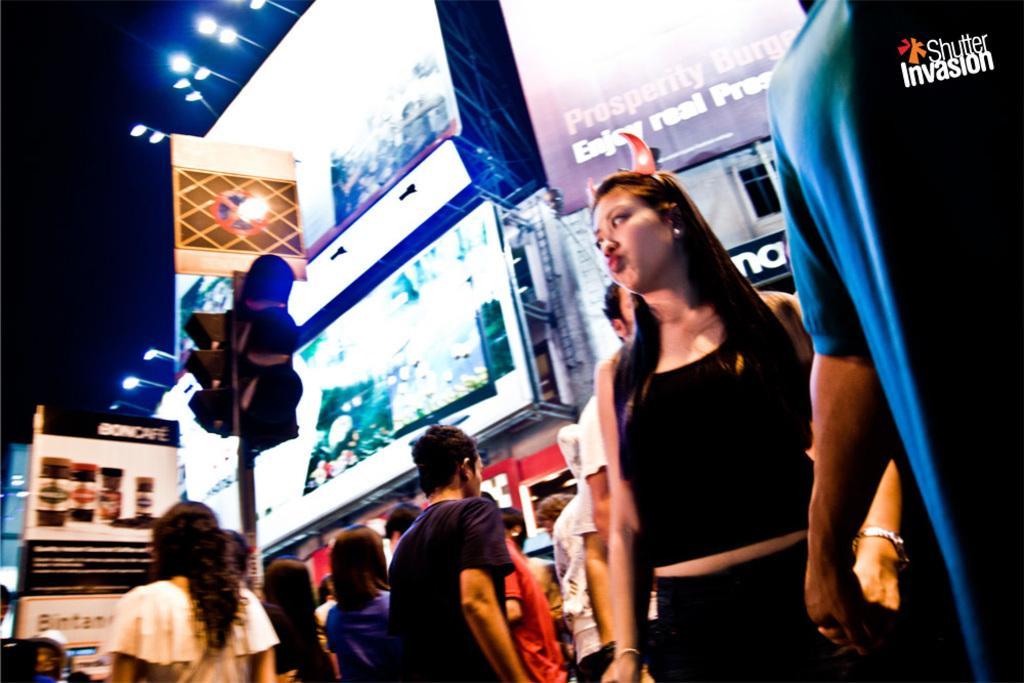In one or two sentences, can you explain what this image depicts? On the right side a woman is standing , she wore a black color dress. On the left side it's a traffic signal, few persons are walking at here and these are the big advertisement boards in the middle of an image. 